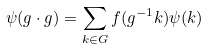Convert formula to latex. <formula><loc_0><loc_0><loc_500><loc_500>\psi ( g \cdot g ) = \sum _ { k \in G } f ( g ^ { - 1 } k ) \psi ( k )</formula> 